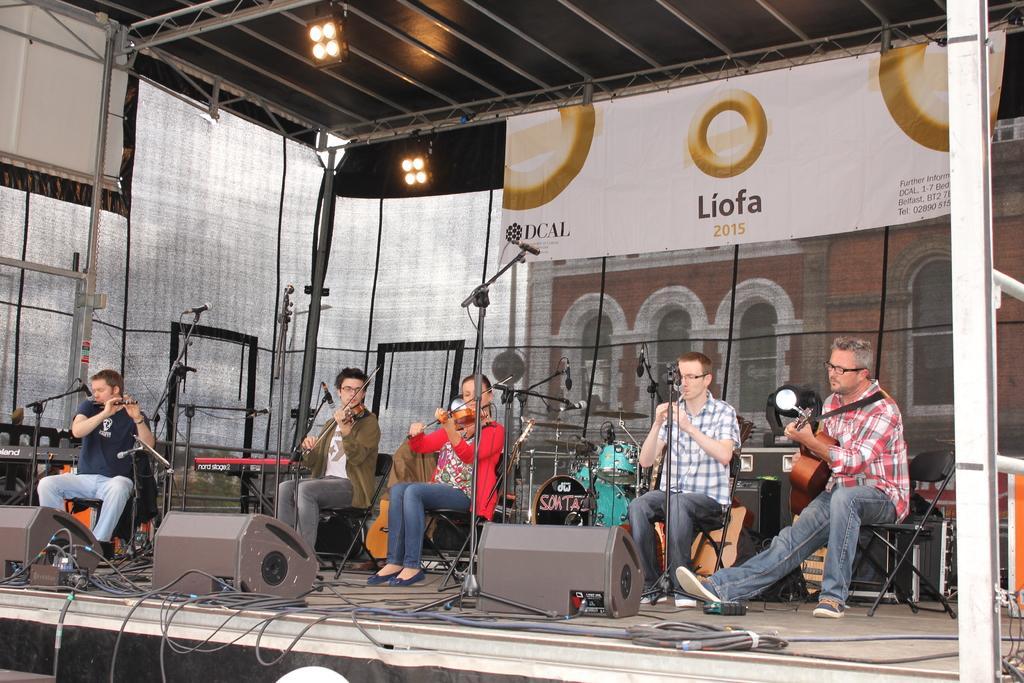Could you give a brief overview of what you see in this image? In this image there is 1 person who is sitting and playing guitar, another 2 persons sitting and playing flute,another 2 persons sitting and playing violin , at the back ground there is drums , microphone, banner, focus light , speaker, cable. 